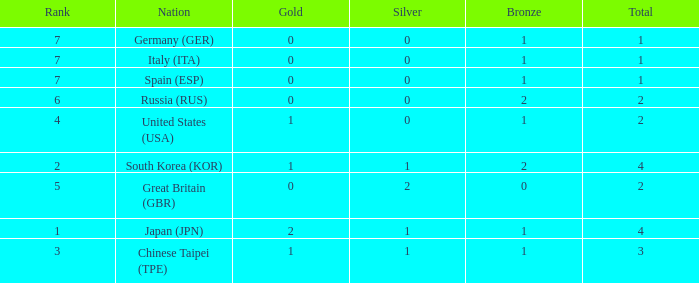What is the rank of the country with more than 2 medals, and 2 gold medals? 1.0. 